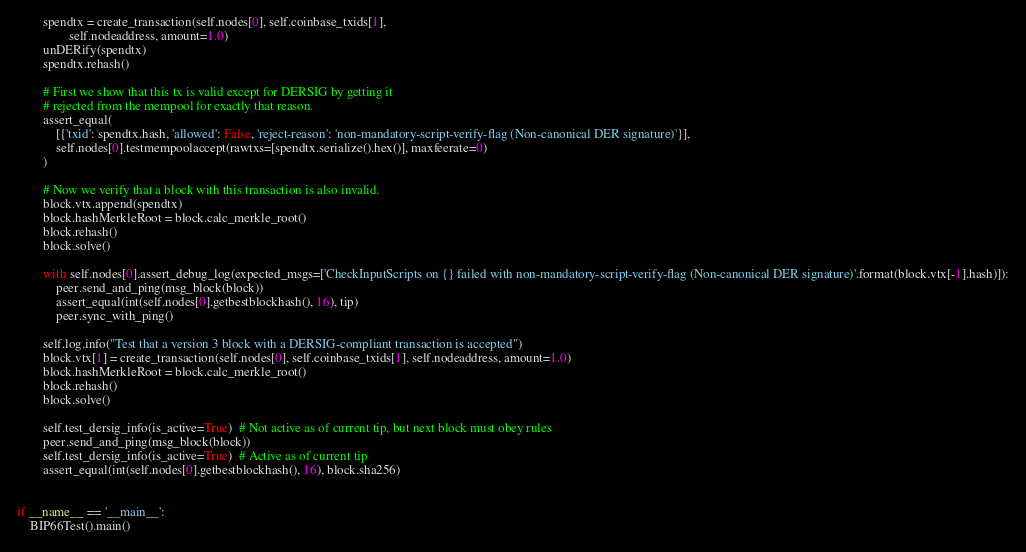<code> <loc_0><loc_0><loc_500><loc_500><_Python_>        spendtx = create_transaction(self.nodes[0], self.coinbase_txids[1],
                self.nodeaddress, amount=1.0)
        unDERify(spendtx)
        spendtx.rehash()

        # First we show that this tx is valid except for DERSIG by getting it
        # rejected from the mempool for exactly that reason.
        assert_equal(
            [{'txid': spendtx.hash, 'allowed': False, 'reject-reason': 'non-mandatory-script-verify-flag (Non-canonical DER signature)'}],
            self.nodes[0].testmempoolaccept(rawtxs=[spendtx.serialize().hex()], maxfeerate=0)
        )

        # Now we verify that a block with this transaction is also invalid.
        block.vtx.append(spendtx)
        block.hashMerkleRoot = block.calc_merkle_root()
        block.rehash()
        block.solve()

        with self.nodes[0].assert_debug_log(expected_msgs=['CheckInputScripts on {} failed with non-mandatory-script-verify-flag (Non-canonical DER signature)'.format(block.vtx[-1].hash)]):
            peer.send_and_ping(msg_block(block))
            assert_equal(int(self.nodes[0].getbestblockhash(), 16), tip)
            peer.sync_with_ping()

        self.log.info("Test that a version 3 block with a DERSIG-compliant transaction is accepted")
        block.vtx[1] = create_transaction(self.nodes[0], self.coinbase_txids[1], self.nodeaddress, amount=1.0)
        block.hashMerkleRoot = block.calc_merkle_root()
        block.rehash()
        block.solve()

        self.test_dersig_info(is_active=True)  # Not active as of current tip, but next block must obey rules
        peer.send_and_ping(msg_block(block))
        self.test_dersig_info(is_active=True)  # Active as of current tip
        assert_equal(int(self.nodes[0].getbestblockhash(), 16), block.sha256)


if __name__ == '__main__':
    BIP66Test().main()
</code> 